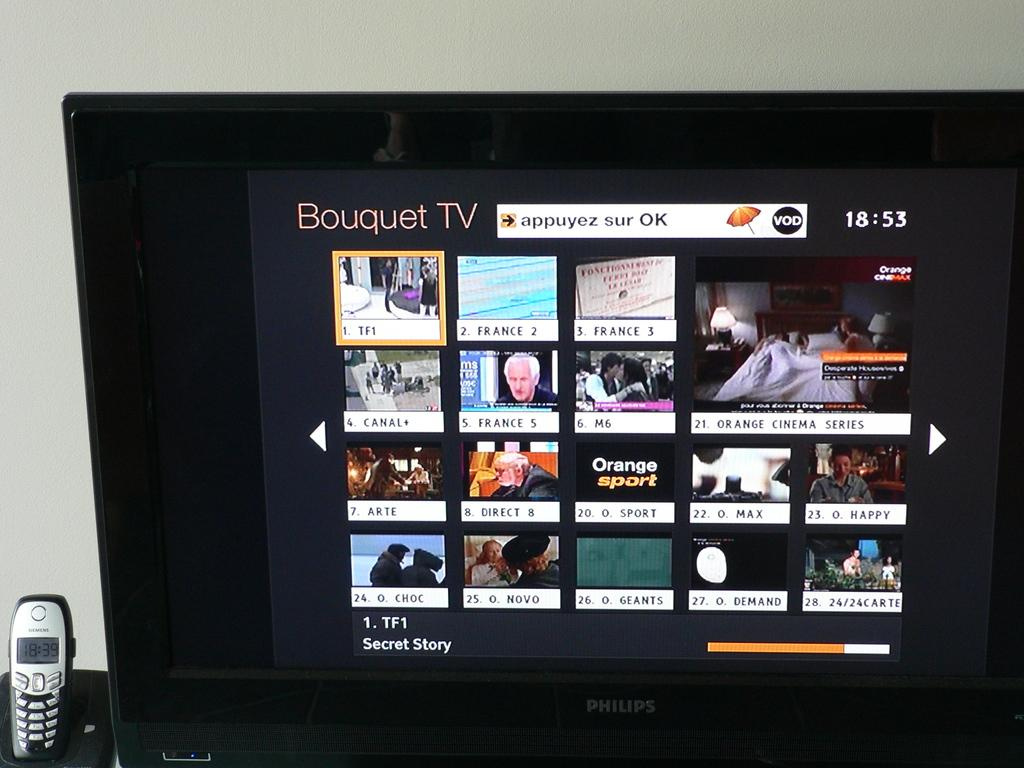<image>
Present a compact description of the photo's key features. A screen of Bouquet TV showing different channels available at 18:53. 